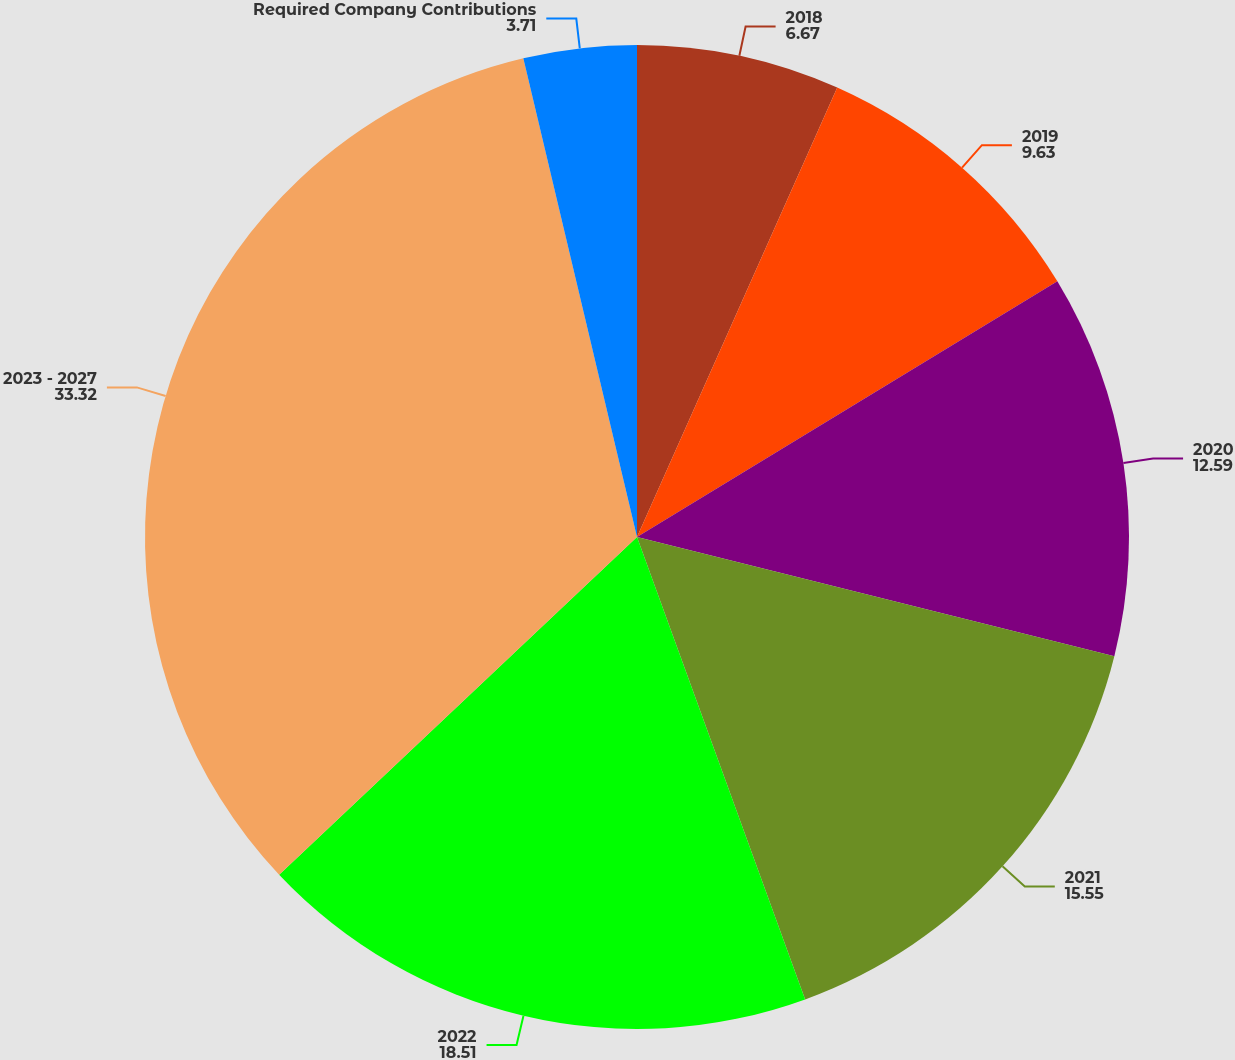<chart> <loc_0><loc_0><loc_500><loc_500><pie_chart><fcel>2018<fcel>2019<fcel>2020<fcel>2021<fcel>2022<fcel>2023 - 2027<fcel>Required Company Contributions<nl><fcel>6.67%<fcel>9.63%<fcel>12.59%<fcel>15.55%<fcel>18.51%<fcel>33.32%<fcel>3.71%<nl></chart> 